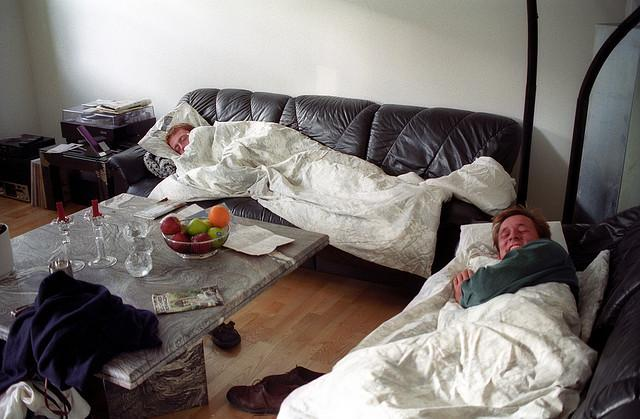What is the bowl holding the fruit made from?

Choices:
A) wood
B) plastic
C) steel
D) glass glass 